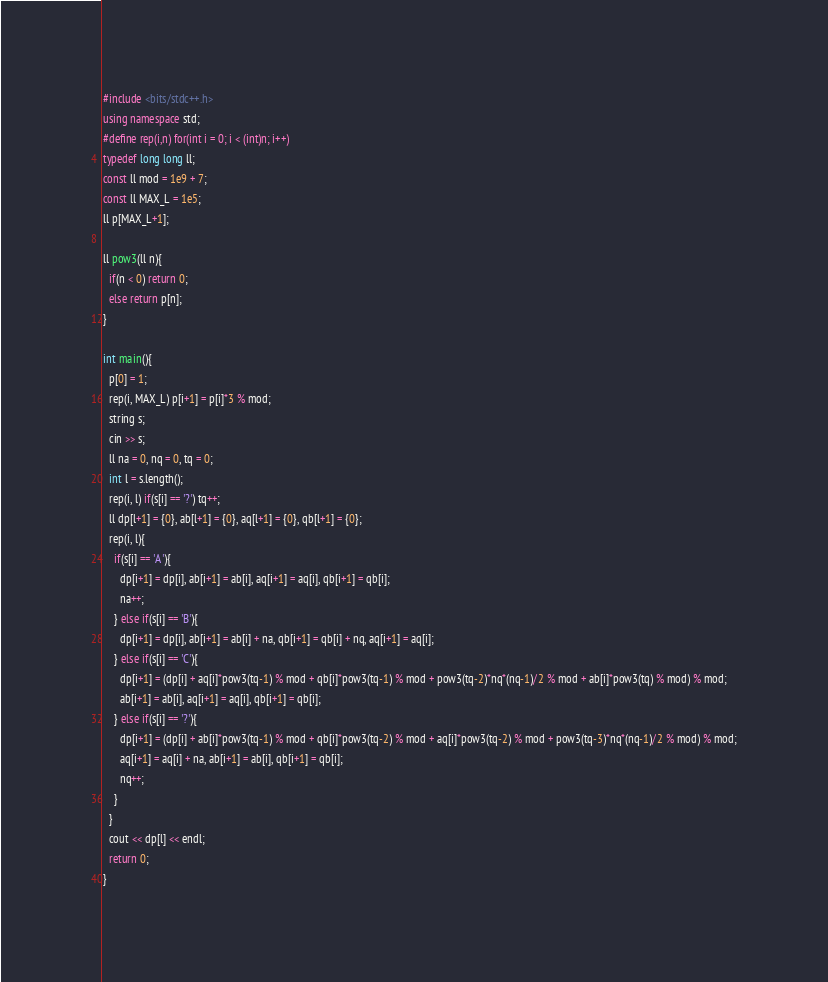<code> <loc_0><loc_0><loc_500><loc_500><_C++_>#include <bits/stdc++.h>
using namespace std;
#define rep(i,n) for(int i = 0; i < (int)n; i++)
typedef long long ll;
const ll mod = 1e9 + 7;
const ll MAX_L = 1e5;
ll p[MAX_L+1];

ll pow3(ll n){
  if(n < 0) return 0;
  else return p[n];
}

int main(){
  p[0] = 1;
  rep(i, MAX_L) p[i+1] = p[i]*3 % mod;
  string s;
  cin >> s;
  ll na = 0, nq = 0, tq = 0;
  int l = s.length();
  rep(i, l) if(s[i] == '?') tq++;
  ll dp[l+1] = {0}, ab[l+1] = {0}, aq[l+1] = {0}, qb[l+1] = {0};
  rep(i, l){
    if(s[i] == 'A'){
      dp[i+1] = dp[i], ab[i+1] = ab[i], aq[i+1] = aq[i], qb[i+1] = qb[i];
      na++;
    } else if(s[i] == 'B'){
      dp[i+1] = dp[i], ab[i+1] = ab[i] + na, qb[i+1] = qb[i] + nq, aq[i+1] = aq[i];
    } else if(s[i] == 'C'){
      dp[i+1] = (dp[i] + aq[i]*pow3(tq-1) % mod + qb[i]*pow3(tq-1) % mod + pow3(tq-2)*nq*(nq-1)/2 % mod + ab[i]*pow3(tq) % mod) % mod;
      ab[i+1] = ab[i], aq[i+1] = aq[i], qb[i+1] = qb[i];
    } else if(s[i] == '?'){
      dp[i+1] = (dp[i] + ab[i]*pow3(tq-1) % mod + qb[i]*pow3(tq-2) % mod + aq[i]*pow3(tq-2) % mod + pow3(tq-3)*nq*(nq-1)/2 % mod) % mod;
      aq[i+1] = aq[i] + na, ab[i+1] = ab[i], qb[i+1] = qb[i];
      nq++;
    }
  }
  cout << dp[l] << endl;
  return 0;
}
</code> 